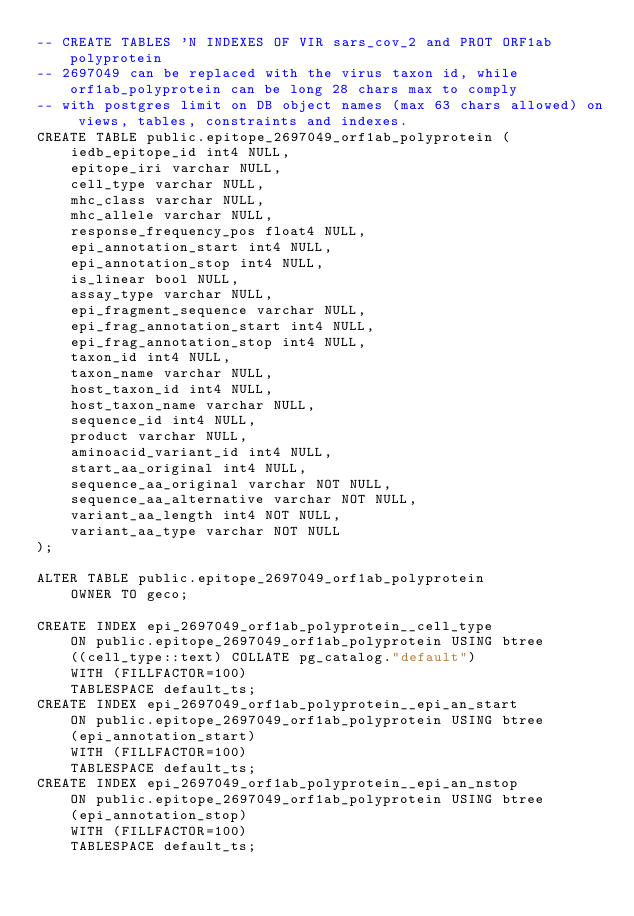<code> <loc_0><loc_0><loc_500><loc_500><_SQL_>-- CREATE TABLES 'N INDEXES OF VIR sars_cov_2 and PROT ORF1ab polyprotein
-- 2697049 can be replaced with the virus taxon id, while orf1ab_polyprotein can be long 28 chars max to comply
-- with postgres limit on DB object names (max 63 chars allowed) on views, tables, constraints and indexes.
CREATE TABLE public.epitope_2697049_orf1ab_polyprotein (
    iedb_epitope_id int4 NULL,
    epitope_iri varchar NULL,
    cell_type varchar NULL,
    mhc_class varchar NULL,
    mhc_allele varchar NULL,
    response_frequency_pos float4 NULL,
    epi_annotation_start int4 NULL,
    epi_annotation_stop int4 NULL,
    is_linear bool NULL,
    assay_type varchar NULL,
    epi_fragment_sequence varchar NULL,
    epi_frag_annotation_start int4 NULL,
    epi_frag_annotation_stop int4 NULL,
    taxon_id int4 NULL,
    taxon_name varchar NULL,
    host_taxon_id int4 NULL,
    host_taxon_name varchar NULL,
    sequence_id int4 NULL,
    product varchar NULL,
    aminoacid_variant_id int4 NULL,
    start_aa_original int4 NULL,
    sequence_aa_original varchar NOT NULL,
    sequence_aa_alternative varchar NOT NULL,
    variant_aa_length int4 NOT NULL,
    variant_aa_type varchar NOT NULL
);

ALTER TABLE public.epitope_2697049_orf1ab_polyprotein
    OWNER TO geco;

CREATE INDEX epi_2697049_orf1ab_polyprotein__cell_type
    ON public.epitope_2697049_orf1ab_polyprotein USING btree
    ((cell_type::text) COLLATE pg_catalog."default")
    WITH (FILLFACTOR=100)
    TABLESPACE default_ts;
CREATE INDEX epi_2697049_orf1ab_polyprotein__epi_an_start
    ON public.epitope_2697049_orf1ab_polyprotein USING btree
    (epi_annotation_start)
    WITH (FILLFACTOR=100)
    TABLESPACE default_ts;
CREATE INDEX epi_2697049_orf1ab_polyprotein__epi_an_nstop
    ON public.epitope_2697049_orf1ab_polyprotein USING btree
    (epi_annotation_stop)
    WITH (FILLFACTOR=100)
    TABLESPACE default_ts;</code> 